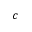Convert formula to latex. <formula><loc_0><loc_0><loc_500><loc_500>c</formula> 